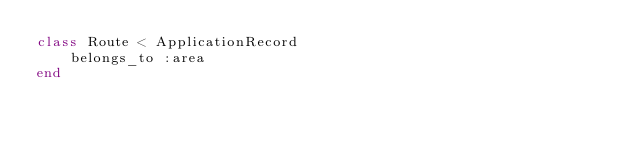<code> <loc_0><loc_0><loc_500><loc_500><_Ruby_>class Route < ApplicationRecord
    belongs_to :area
end
</code> 